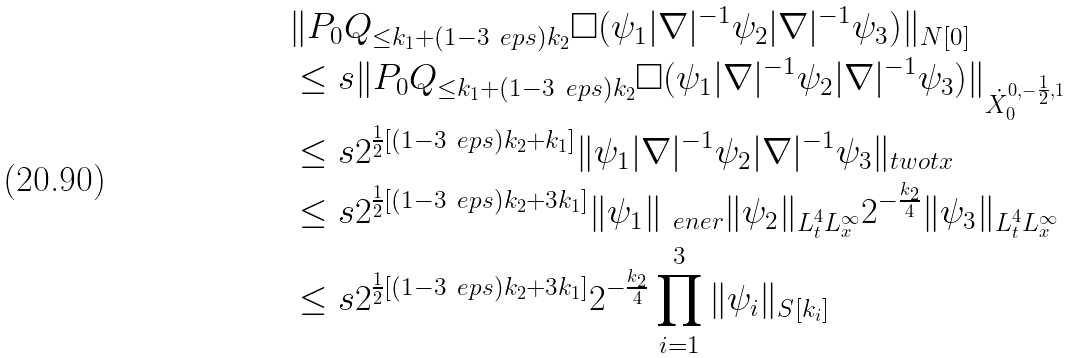Convert formula to latex. <formula><loc_0><loc_0><loc_500><loc_500>& \| P _ { 0 } Q _ { \leq k _ { 1 } + ( 1 - 3 \ e p s ) k _ { 2 } } \Box ( \psi _ { 1 } | \nabla | ^ { - 1 } \psi _ { 2 } | \nabla | ^ { - 1 } \psi _ { 3 } ) \| _ { N [ 0 ] } \\ & \leq s \| P _ { 0 } Q _ { \leq k _ { 1 } + ( 1 - 3 \ e p s ) k _ { 2 } } \Box ( \psi _ { 1 } | \nabla | ^ { - 1 } \psi _ { 2 } | \nabla | ^ { - 1 } \psi _ { 3 } ) \| _ { \dot { X } _ { 0 } ^ { 0 , - \frac { 1 } { 2 } , 1 } } \\ & \leq s 2 ^ { \frac { 1 } { 2 } [ ( 1 - 3 \ e p s ) k _ { 2 } + k _ { 1 } ] } \| \psi _ { 1 } | \nabla | ^ { - 1 } \psi _ { 2 } | \nabla | ^ { - 1 } \psi _ { 3 } \| _ { \L t w o t x } \\ & \leq s 2 ^ { \frac { 1 } { 2 } [ ( 1 - 3 \ e p s ) k _ { 2 } + 3 k _ { 1 } ] } \| \psi _ { 1 } \| _ { \ e n e r } \| \psi _ { 2 } \| _ { L ^ { 4 } _ { t } L ^ { \infty } _ { x } } 2 ^ { - \frac { k _ { 2 } } { 4 } } \| \psi _ { 3 } \| _ { L ^ { 4 } _ { t } L ^ { \infty } _ { x } } \\ & \leq s 2 ^ { \frac { 1 } { 2 } [ ( 1 - 3 \ e p s ) k _ { 2 } + 3 k _ { 1 } ] } 2 ^ { - \frac { k _ { 2 } } { 4 } } \prod _ { i = 1 } ^ { 3 } \| \psi _ { i } \| _ { S [ k _ { i } ] }</formula> 